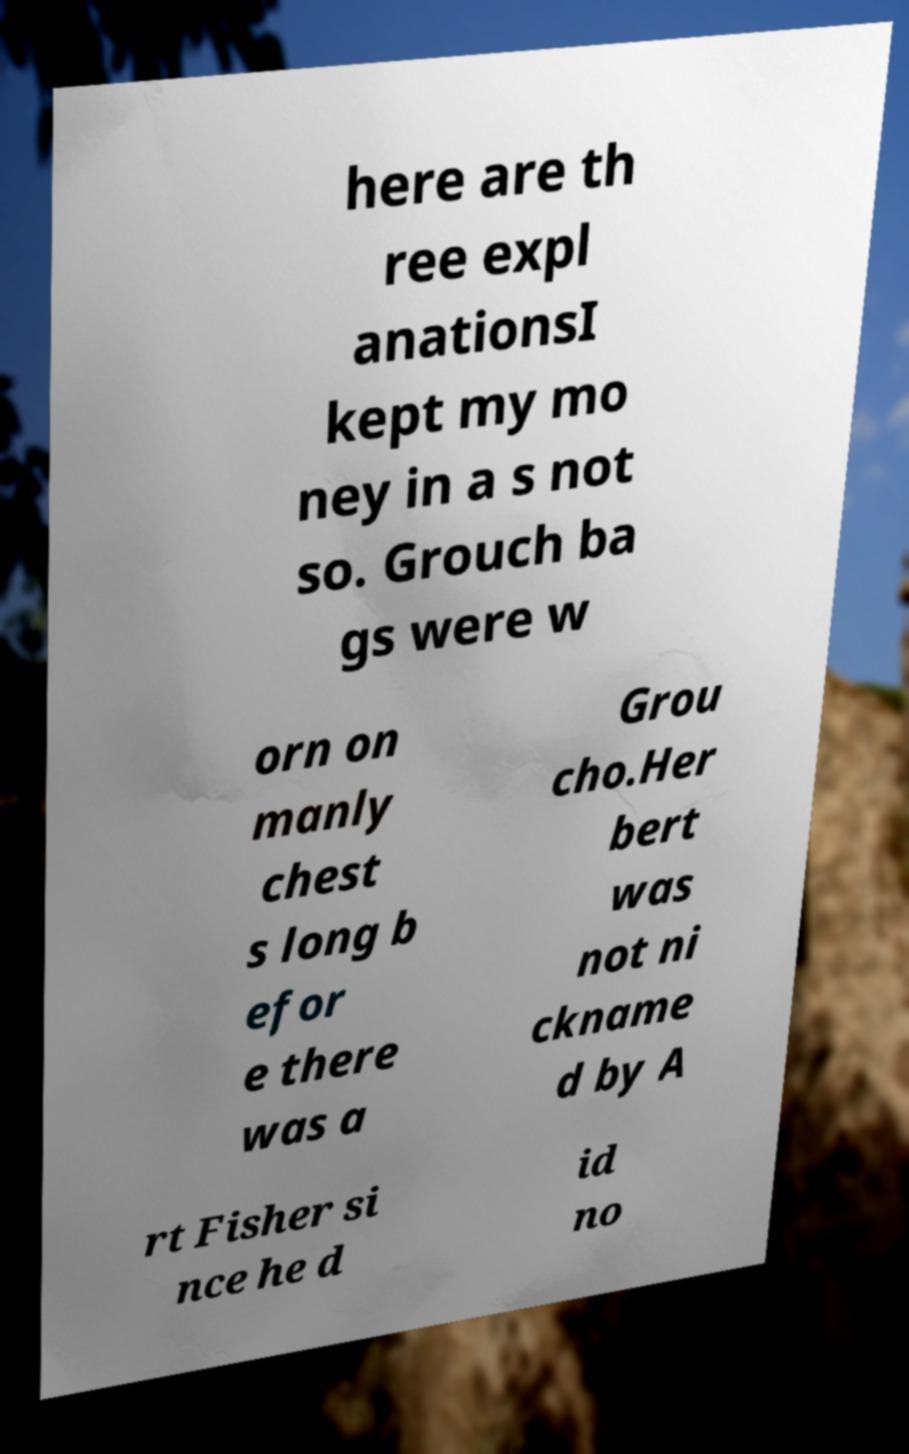For documentation purposes, I need the text within this image transcribed. Could you provide that? here are th ree expl anationsI kept my mo ney in a s not so. Grouch ba gs were w orn on manly chest s long b efor e there was a Grou cho.Her bert was not ni ckname d by A rt Fisher si nce he d id no 